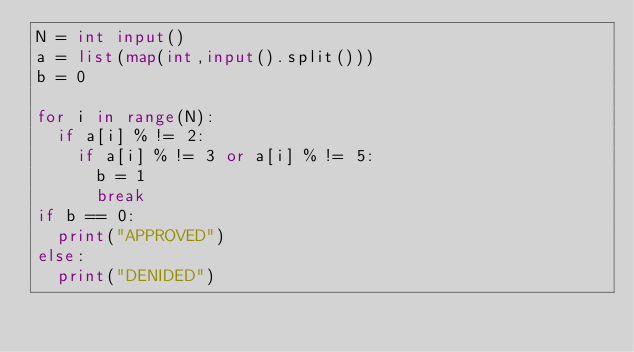Convert code to text. <code><loc_0><loc_0><loc_500><loc_500><_Python_>N = int input()
a = list(map(int,input().split()))
b = 0

for i in range(N):
  if a[i] % != 2:
    if a[i] % != 3 or a[i] % != 5:
      b = 1
      break
if b == 0:
  print("APPROVED")
else:
  print("DENIDED")
</code> 